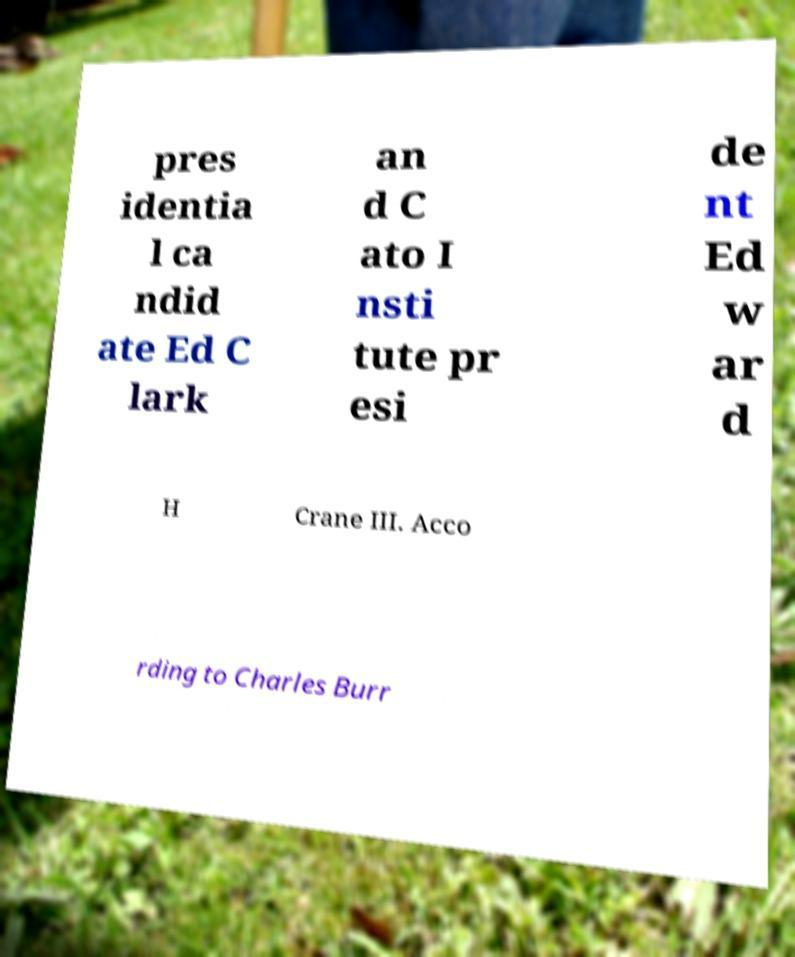Please read and relay the text visible in this image. What does it say? pres identia l ca ndid ate Ed C lark an d C ato I nsti tute pr esi de nt Ed w ar d H Crane III. Acco rding to Charles Burr 